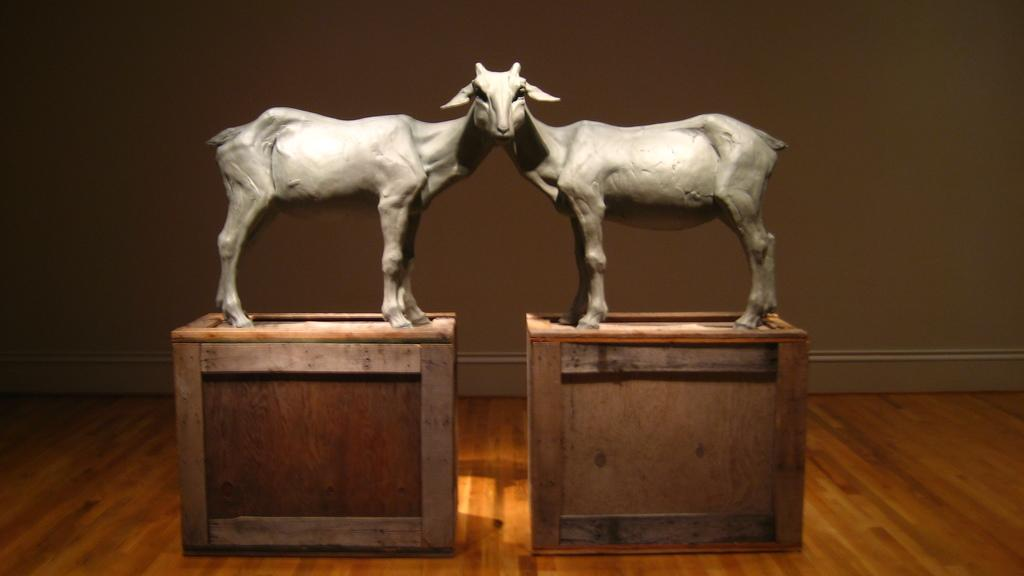What type of animal is depicted in the statues in the image? The statues in the image are of goats. How many heads do the goat statues have? The goat statues have a single head. What are the goat statues placed on? The goat statues are on books. What else can be seen on the floor in the image? There are books on the floor in the image. What advice does the mother give to the child in the image? There is no mother or child present in the image; it features goat statues on books. 